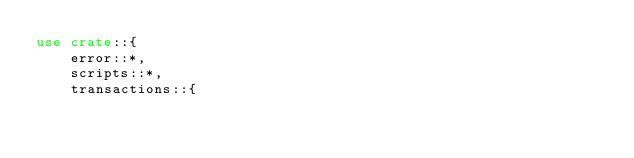Convert code to text. <code><loc_0><loc_0><loc_500><loc_500><_Rust_>use crate::{
    error::*,
    scripts::*,
    transactions::{</code> 